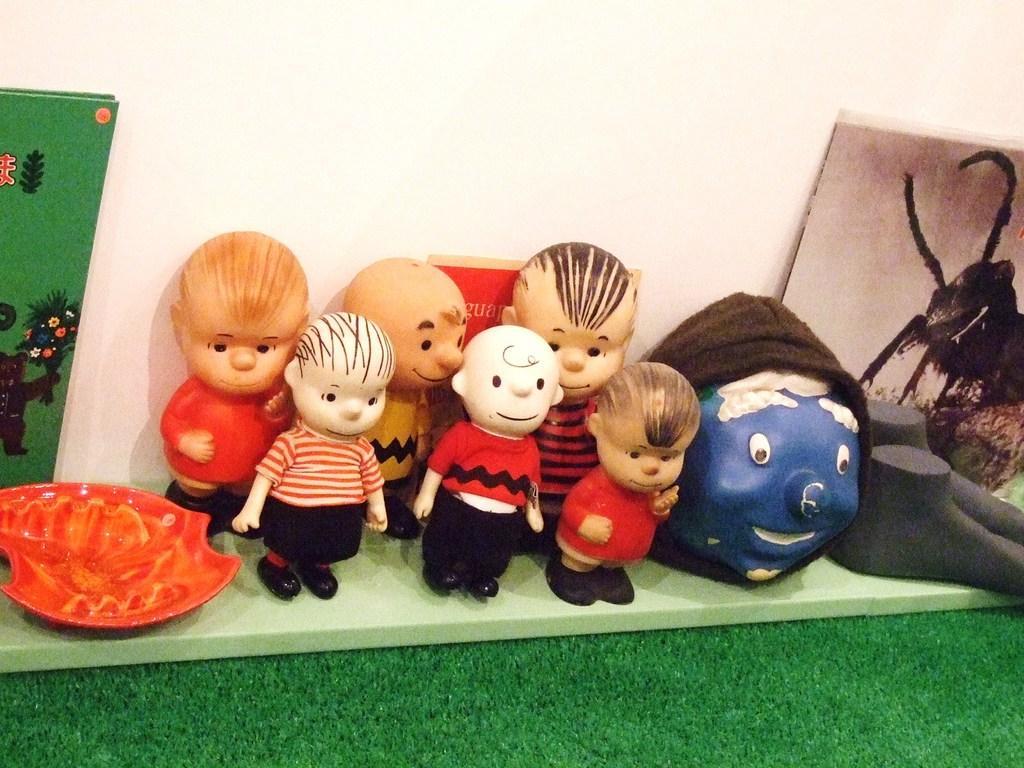Describe this image in one or two sentences. In this picture I can observe some toys which are in red and black colors. In the background there is a wall. 